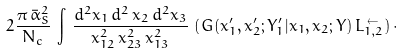Convert formula to latex. <formula><loc_0><loc_0><loc_500><loc_500>2 \frac { \pi \, \bar { \alpha } ^ { 2 } _ { S } } { N _ { c } } \, \int \, \frac { d ^ { 2 } x _ { 1 } \, d ^ { 2 } \, x _ { 2 } \, d ^ { 2 } x _ { 3 } } { x ^ { 2 } _ { 1 2 } \, x ^ { 2 } _ { 2 3 } \, x ^ { 2 } _ { 1 3 } } \, \left ( G ( x ^ { \prime } _ { 1 } , x ^ { \prime } _ { 2 } ; Y ^ { \prime } _ { 1 } | x _ { 1 } , x _ { 2 } ; Y ) \, L ^ { \, \leftarrow } _ { 1 , 2 } \right ) \cdot</formula> 